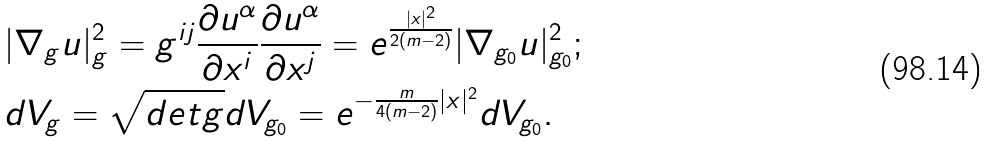<formula> <loc_0><loc_0><loc_500><loc_500>& | \nabla _ { g } u | ^ { 2 } _ { g } = g ^ { i j } \frac { \partial u ^ { \alpha } } { \partial x ^ { i } } \frac { \partial u ^ { \alpha } } { \partial x ^ { j } } = e ^ { \frac { | x | ^ { 2 } } { 2 ( m - 2 ) } } | \nabla _ { g _ { 0 } } u | ^ { 2 } _ { g _ { 0 } } ; \\ & d V _ { g } = \sqrt { d e t g } d V _ { g _ { 0 } } = e ^ { - \frac { m } { 4 ( m - 2 ) } | x | ^ { 2 } } d V _ { g _ { 0 } } . \\</formula> 